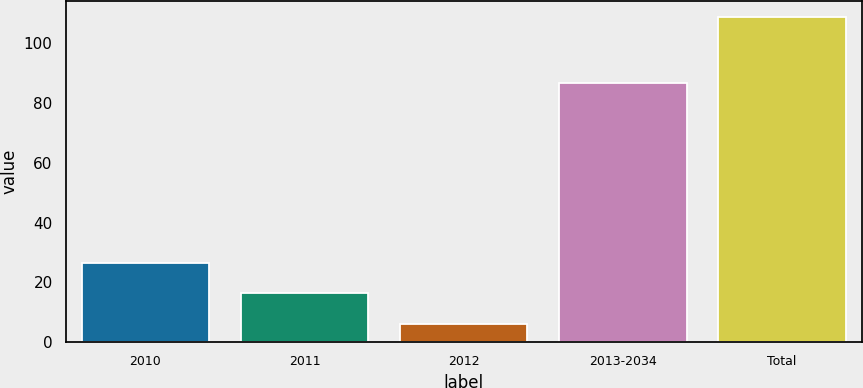Convert chart to OTSL. <chart><loc_0><loc_0><loc_500><loc_500><bar_chart><fcel>2010<fcel>2011<fcel>2012<fcel>2013-2034<fcel>Total<nl><fcel>26.54<fcel>16.27<fcel>6<fcel>86.8<fcel>108.7<nl></chart> 